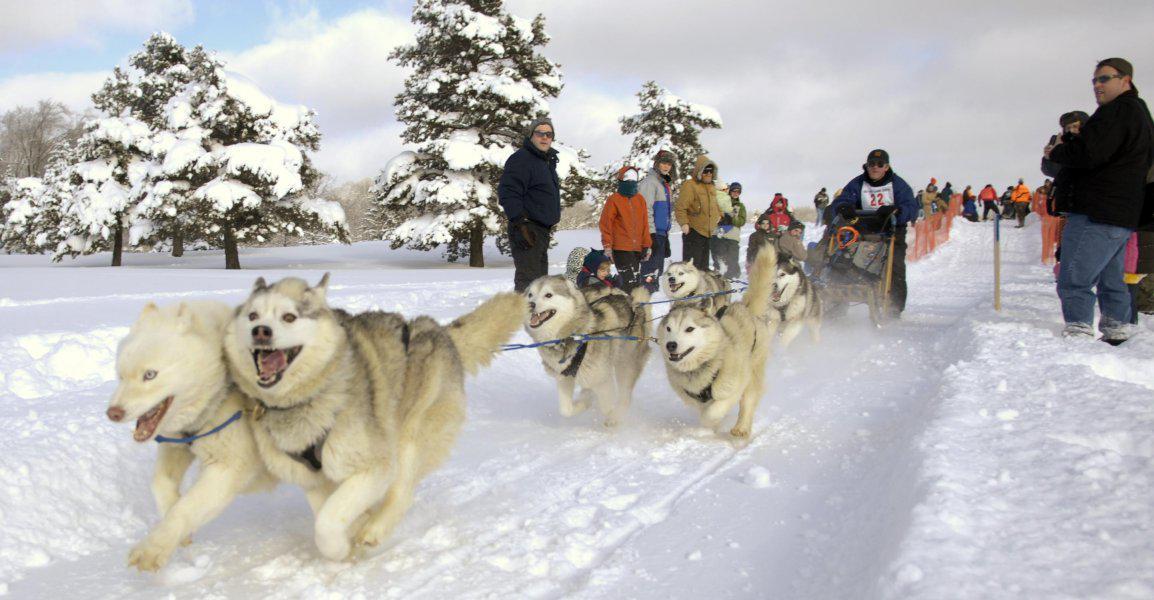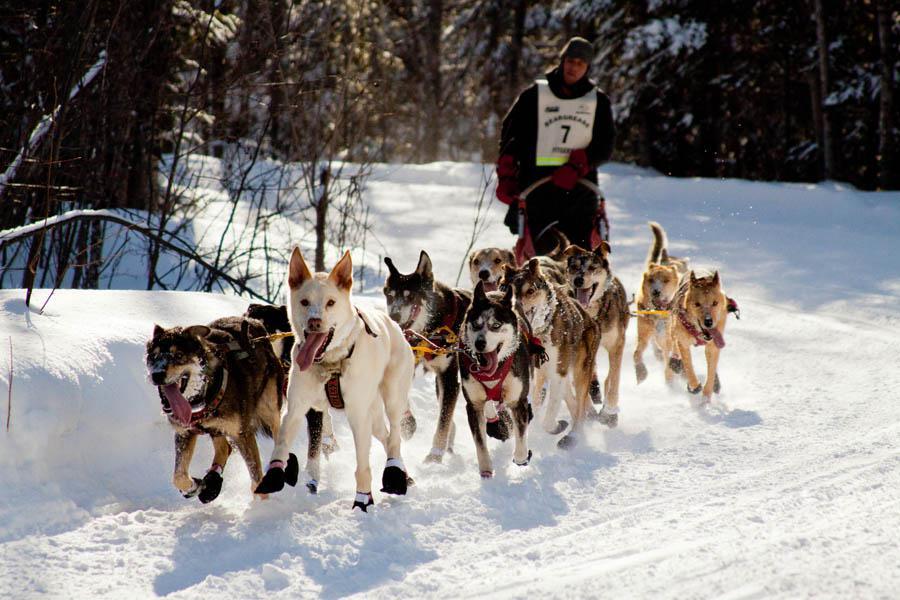The first image is the image on the left, the second image is the image on the right. Analyze the images presented: Is the assertion "In at least one image there are are at least five huskey moving left with doggy boots covering their paws." valid? Answer yes or no. Yes. The first image is the image on the left, the second image is the image on the right. Examine the images to the left and right. Is the description "The sled dogs in the images are running in the same general direction." accurate? Answer yes or no. Yes. 